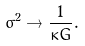<formula> <loc_0><loc_0><loc_500><loc_500>\sigma ^ { 2 } \rightarrow \frac { 1 } { \kappa G } .</formula> 